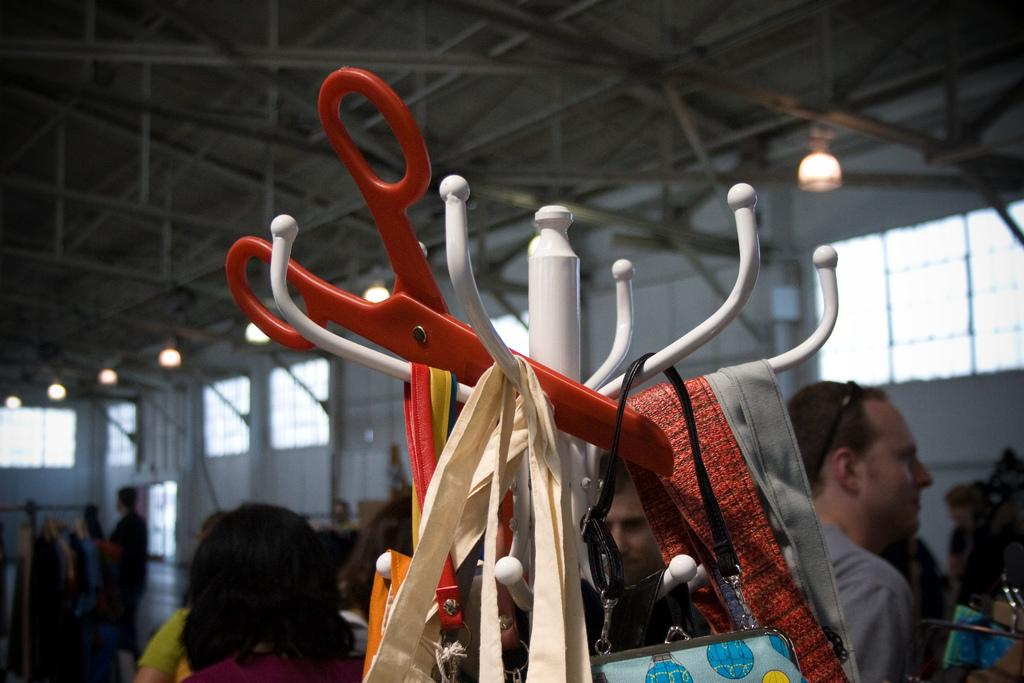What can be seen hanging in the image? There is a hanger in the image, with many handbags hanging on it. What are the people around wearing? The people around are wearing clothes. What can be seen in the background of the image? There are windows and lights visible in the image. What type of location is depicted in the image? This is a roof. What advice can be seen written on the mailbox in the image? There is no mailbox present in the image, so no advice can be seen written on it. 